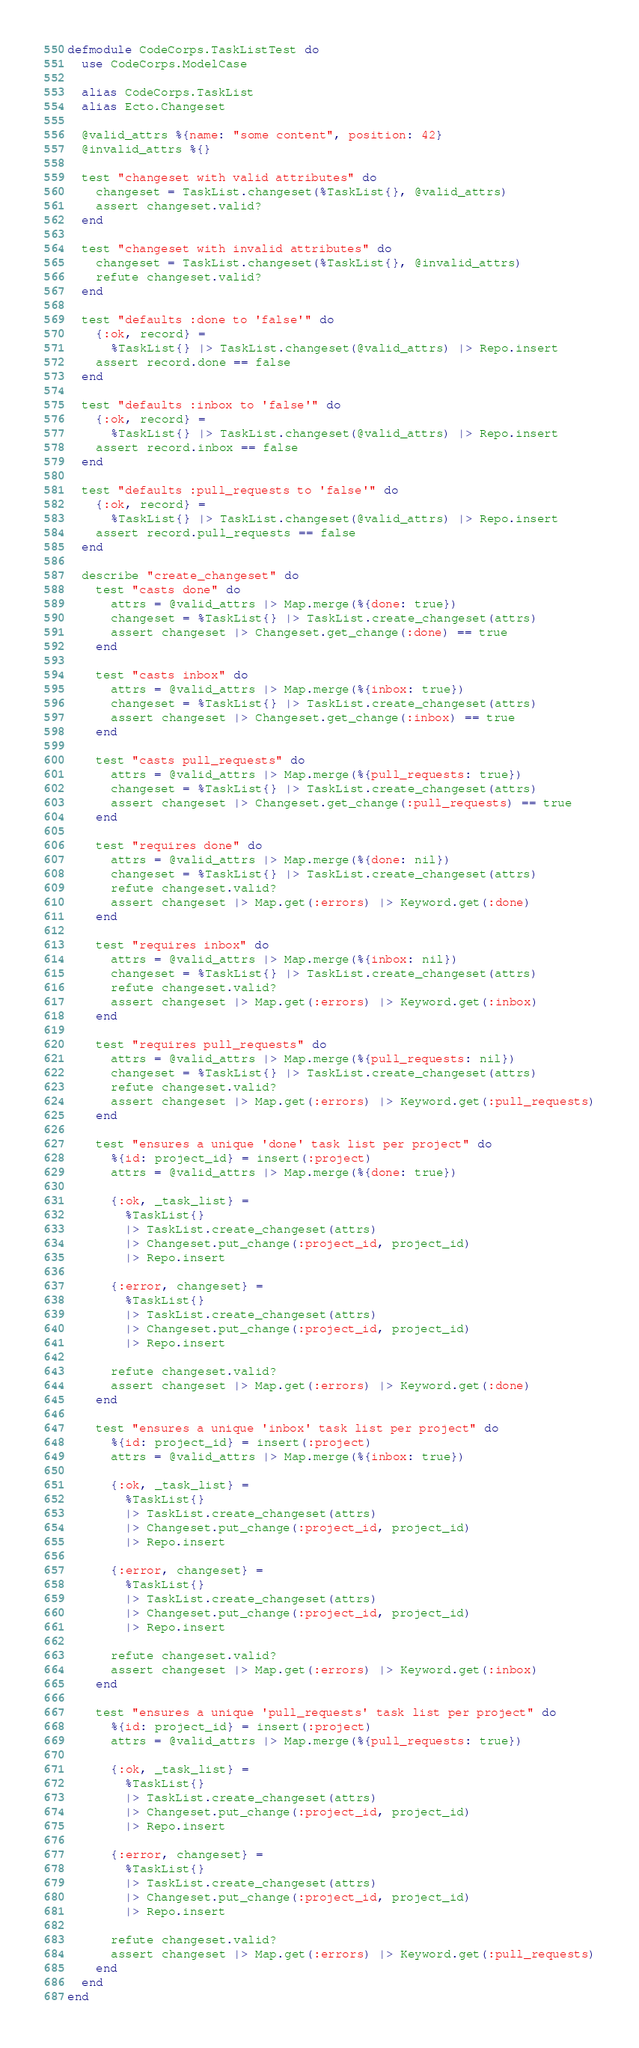Convert code to text. <code><loc_0><loc_0><loc_500><loc_500><_Elixir_>defmodule CodeCorps.TaskListTest do
  use CodeCorps.ModelCase

  alias CodeCorps.TaskList
  alias Ecto.Changeset

  @valid_attrs %{name: "some content", position: 42}
  @invalid_attrs %{}

  test "changeset with valid attributes" do
    changeset = TaskList.changeset(%TaskList{}, @valid_attrs)
    assert changeset.valid?
  end

  test "changeset with invalid attributes" do
    changeset = TaskList.changeset(%TaskList{}, @invalid_attrs)
    refute changeset.valid?
  end

  test "defaults :done to 'false'" do
    {:ok, record} =
      %TaskList{} |> TaskList.changeset(@valid_attrs) |> Repo.insert
    assert record.done == false
  end

  test "defaults :inbox to 'false'" do
    {:ok, record} =
      %TaskList{} |> TaskList.changeset(@valid_attrs) |> Repo.insert
    assert record.inbox == false
  end

  test "defaults :pull_requests to 'false'" do
    {:ok, record} =
      %TaskList{} |> TaskList.changeset(@valid_attrs) |> Repo.insert
    assert record.pull_requests == false
  end

  describe "create_changeset" do
    test "casts done" do
      attrs = @valid_attrs |> Map.merge(%{done: true})
      changeset = %TaskList{} |> TaskList.create_changeset(attrs)
      assert changeset |> Changeset.get_change(:done) == true
    end

    test "casts inbox" do
      attrs = @valid_attrs |> Map.merge(%{inbox: true})
      changeset = %TaskList{} |> TaskList.create_changeset(attrs)
      assert changeset |> Changeset.get_change(:inbox) == true
    end

    test "casts pull_requests" do
      attrs = @valid_attrs |> Map.merge(%{pull_requests: true})
      changeset = %TaskList{} |> TaskList.create_changeset(attrs)
      assert changeset |> Changeset.get_change(:pull_requests) == true
    end

    test "requires done" do
      attrs = @valid_attrs |> Map.merge(%{done: nil})
      changeset = %TaskList{} |> TaskList.create_changeset(attrs)
      refute changeset.valid?
      assert changeset |> Map.get(:errors) |> Keyword.get(:done)
    end

    test "requires inbox" do
      attrs = @valid_attrs |> Map.merge(%{inbox: nil})
      changeset = %TaskList{} |> TaskList.create_changeset(attrs)
      refute changeset.valid?
      assert changeset |> Map.get(:errors) |> Keyword.get(:inbox)
    end

    test "requires pull_requests" do
      attrs = @valid_attrs |> Map.merge(%{pull_requests: nil})
      changeset = %TaskList{} |> TaskList.create_changeset(attrs)
      refute changeset.valid?
      assert changeset |> Map.get(:errors) |> Keyword.get(:pull_requests)
    end

    test "ensures a unique 'done' task list per project" do
      %{id: project_id} = insert(:project)
      attrs = @valid_attrs |> Map.merge(%{done: true})

      {:ok, _task_list} =
        %TaskList{}
        |> TaskList.create_changeset(attrs)
        |> Changeset.put_change(:project_id, project_id)
        |> Repo.insert

      {:error, changeset} =
        %TaskList{}
        |> TaskList.create_changeset(attrs)
        |> Changeset.put_change(:project_id, project_id)
        |> Repo.insert

      refute changeset.valid?
      assert changeset |> Map.get(:errors) |> Keyword.get(:done)
    end

    test "ensures a unique 'inbox' task list per project" do
      %{id: project_id} = insert(:project)
      attrs = @valid_attrs |> Map.merge(%{inbox: true})

      {:ok, _task_list} =
        %TaskList{}
        |> TaskList.create_changeset(attrs)
        |> Changeset.put_change(:project_id, project_id)
        |> Repo.insert

      {:error, changeset} =
        %TaskList{}
        |> TaskList.create_changeset(attrs)
        |> Changeset.put_change(:project_id, project_id)
        |> Repo.insert

      refute changeset.valid?
      assert changeset |> Map.get(:errors) |> Keyword.get(:inbox)
    end

    test "ensures a unique 'pull_requests' task list per project" do
      %{id: project_id} = insert(:project)
      attrs = @valid_attrs |> Map.merge(%{pull_requests: true})

      {:ok, _task_list} =
        %TaskList{}
        |> TaskList.create_changeset(attrs)
        |> Changeset.put_change(:project_id, project_id)
        |> Repo.insert

      {:error, changeset} =
        %TaskList{}
        |> TaskList.create_changeset(attrs)
        |> Changeset.put_change(:project_id, project_id)
        |> Repo.insert

      refute changeset.valid?
      assert changeset |> Map.get(:errors) |> Keyword.get(:pull_requests)
    end
  end
end
</code> 